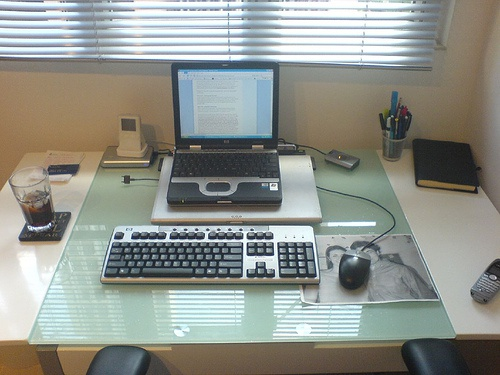Describe the objects in this image and their specific colors. I can see laptop in darkgray, black, gray, and lightblue tones, keyboard in darkgray, black, lightgray, and gray tones, chair in darkgray, black, gray, and purple tones, book in darkgray, black, and olive tones, and cup in darkgray, gray, black, and tan tones in this image. 